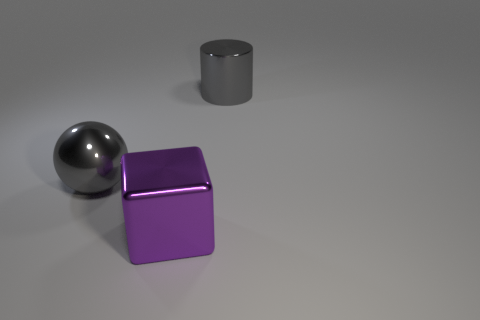Add 3 tiny red things. How many objects exist? 6 Subtract all cylinders. How many objects are left? 2 Add 1 large metallic balls. How many large metallic balls exist? 2 Subtract 1 gray spheres. How many objects are left? 2 Subtract all small cyan balls. Subtract all shiny cylinders. How many objects are left? 2 Add 3 large metallic things. How many large metallic things are left? 6 